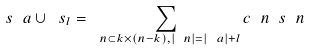Convert formula to latex. <formula><loc_0><loc_0><loc_500><loc_500>\ s _ { \ } a \cup \ s _ { l } = \sum _ { \ n \subset k \times ( n - k ) , | \ n | = | \ a | + l } c _ { \ } n \ s _ { \ } n</formula> 